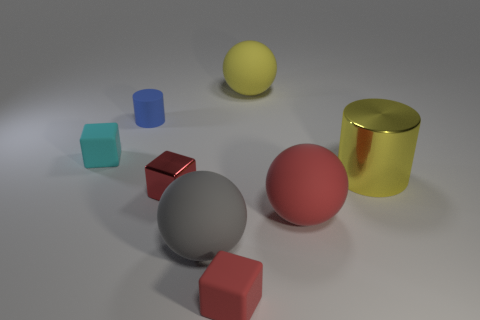Add 2 tiny red things. How many objects exist? 10 Subtract all spheres. How many objects are left? 5 Subtract all gray balls. Subtract all large rubber objects. How many objects are left? 4 Add 7 red balls. How many red balls are left? 8 Add 4 small brown metal cubes. How many small brown metal cubes exist? 4 Subtract 2 red cubes. How many objects are left? 6 